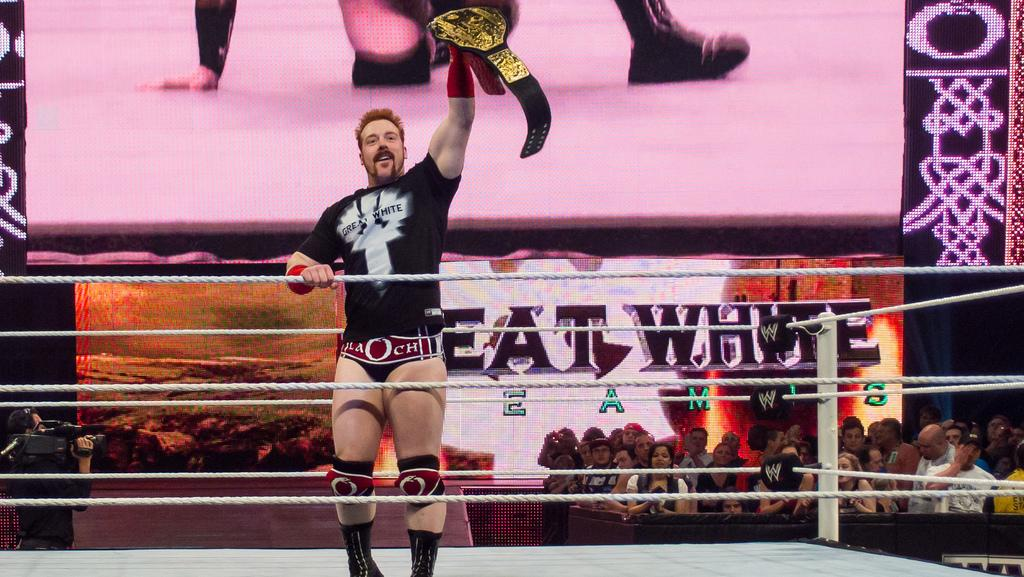Provide a one-sentence caption for the provided image. A wrestler holds his winning belt aloft in front of a "Great White" banner. 